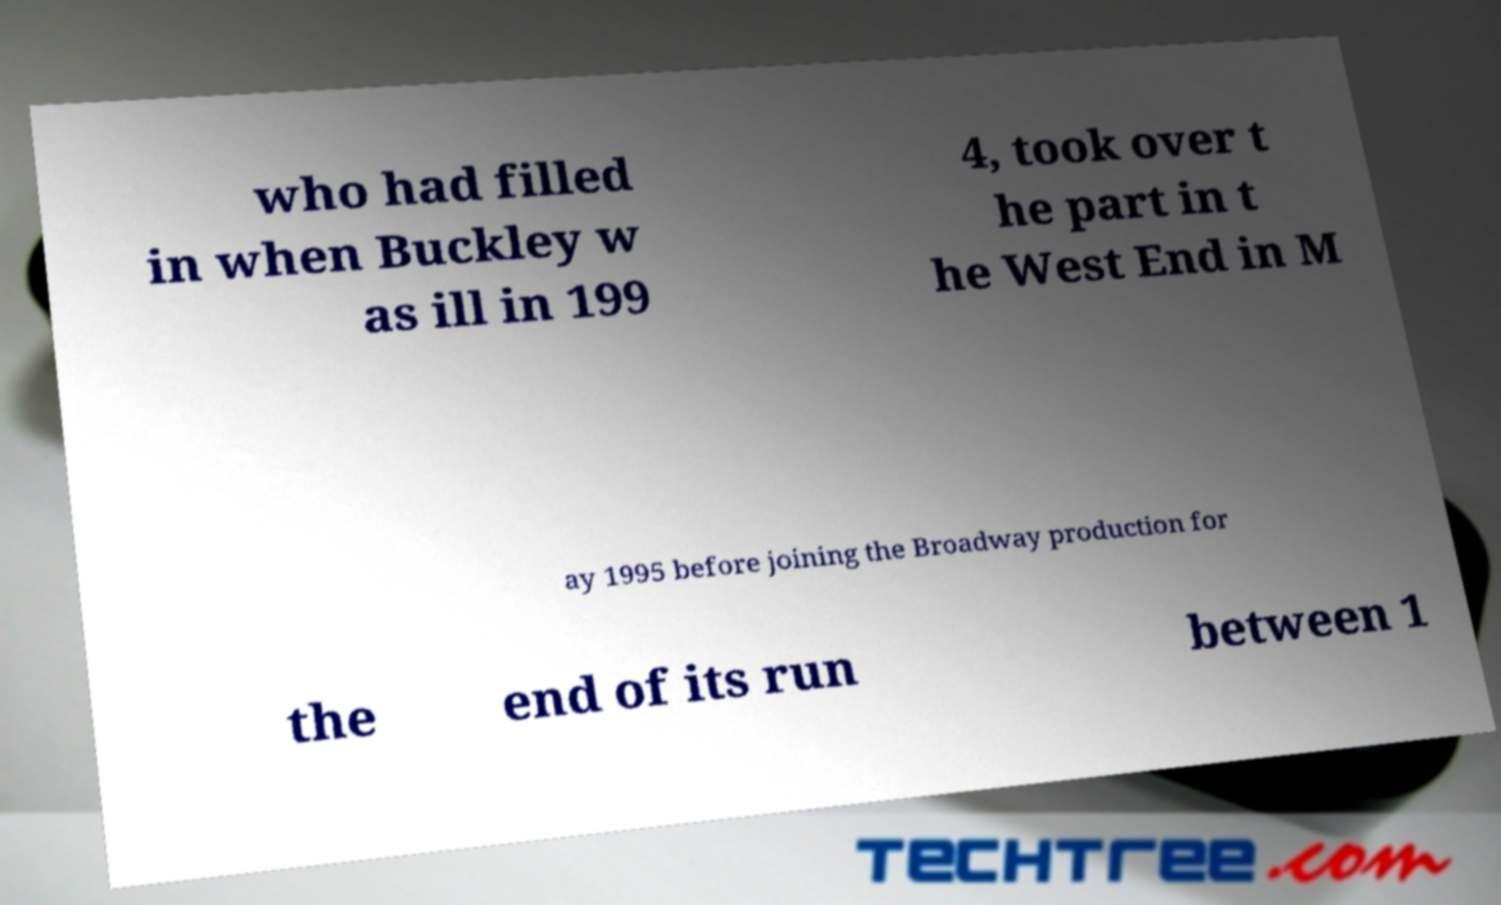Can you read and provide the text displayed in the image?This photo seems to have some interesting text. Can you extract and type it out for me? who had filled in when Buckley w as ill in 199 4, took over t he part in t he West End in M ay 1995 before joining the Broadway production for the end of its run between 1 